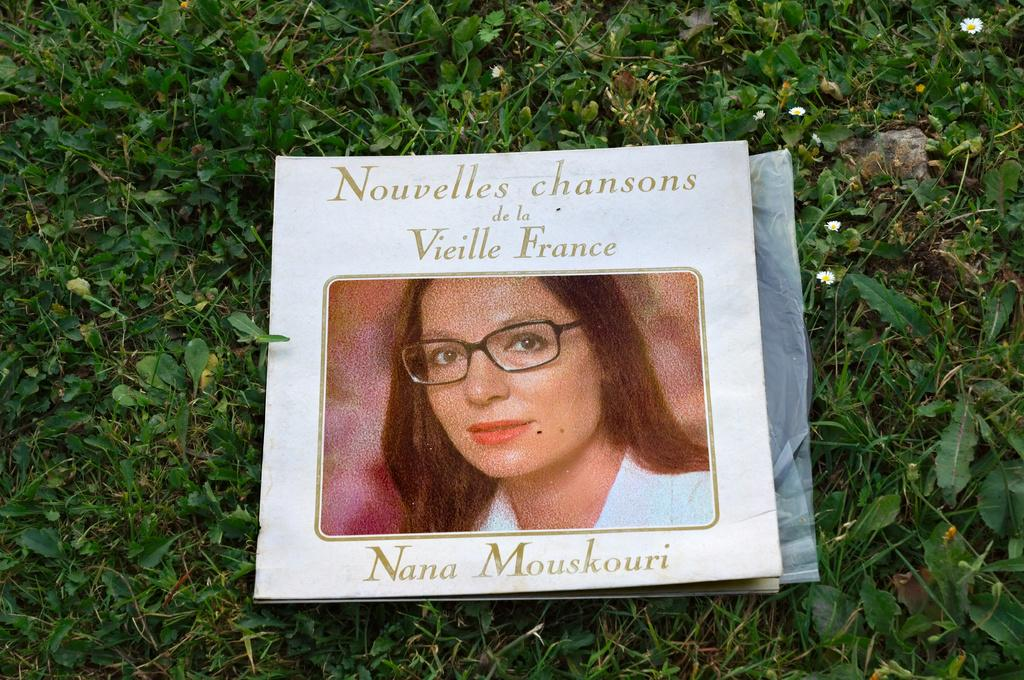What is depicted on the paper in the image? There is a paper with a photo of a woman in the image. What else can be seen on the paper besides the photo? There is something written on the paper. What type of plants are present in the image? There are flower plants in the image. What is the color of the flowers? The flowers are white in color. What type of power does the woman in the photo offer to the viewer in the image? There is no indication of any power being offered by the woman in the photo, as the image only shows a paper with her photo and some writing. 